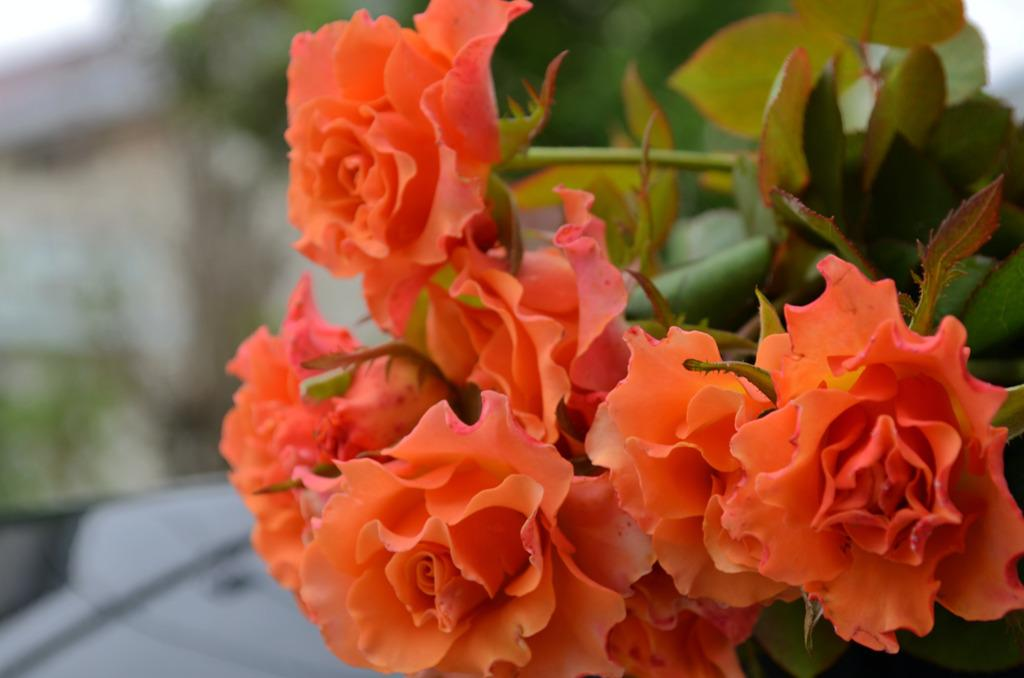What color are the flowers on the plant in the image? The flowers on the plant are orange in color. Can you describe the quality of the image at the back? The image is blurry at the back. Is there a man in the image helping the plant grow? There is no man present in the image, and the image does not depict any actions related to plant growth. 